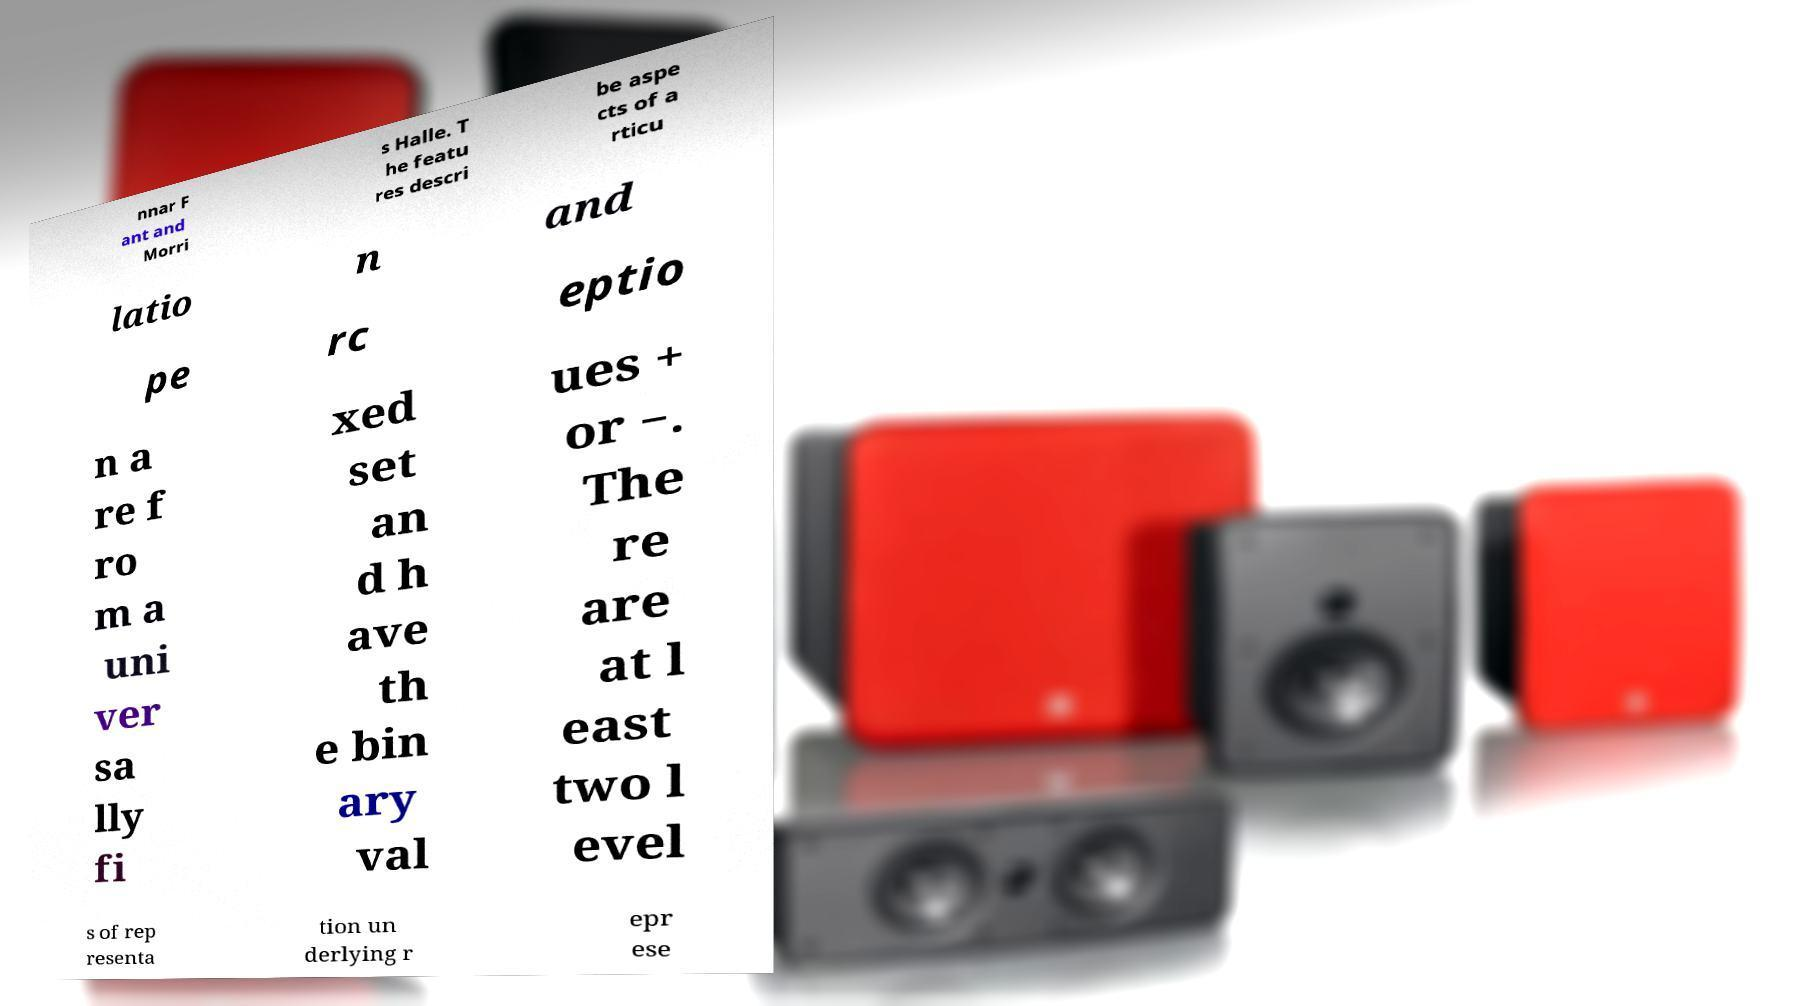Could you extract and type out the text from this image? nnar F ant and Morri s Halle. T he featu res descri be aspe cts of a rticu latio n and pe rc eptio n a re f ro m a uni ver sa lly fi xed set an d h ave th e bin ary val ues + or −. The re are at l east two l evel s of rep resenta tion un derlying r epr ese 